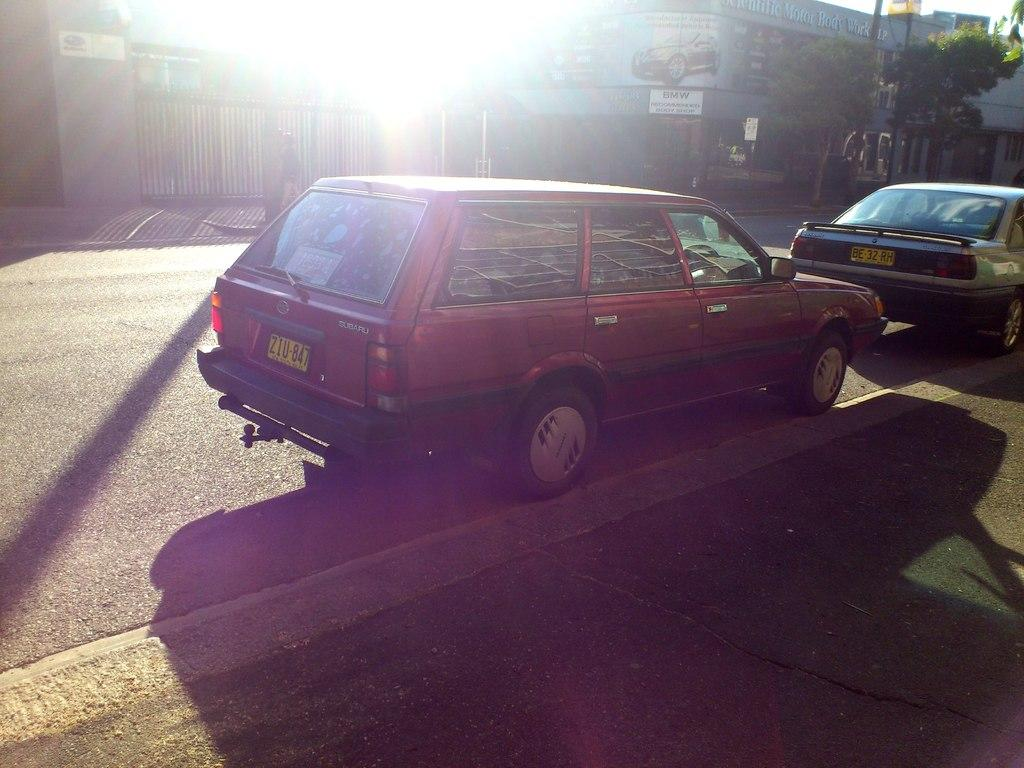What type of structures can be seen in the image? There are buildings in the image. What architectural feature is present in the image? There are stairs in the image. What type of vegetation is visible in the image? There are trees in the image. What type of signage or display is present in the image? There are boards in the image. What type of entrance or exit is present in the image? There is a gate in the image. What type of transportation is visible on the road in the image? There are vehicles on the road in the image. What is the fifth color used in the image? There is no mention of colors in the provided facts, so it is impossible to determine the fifth color used in the image. Can you describe the ray of light shining through the trees in the image? There is no mention of a ray of light in the provided facts, so it cannot be described. 